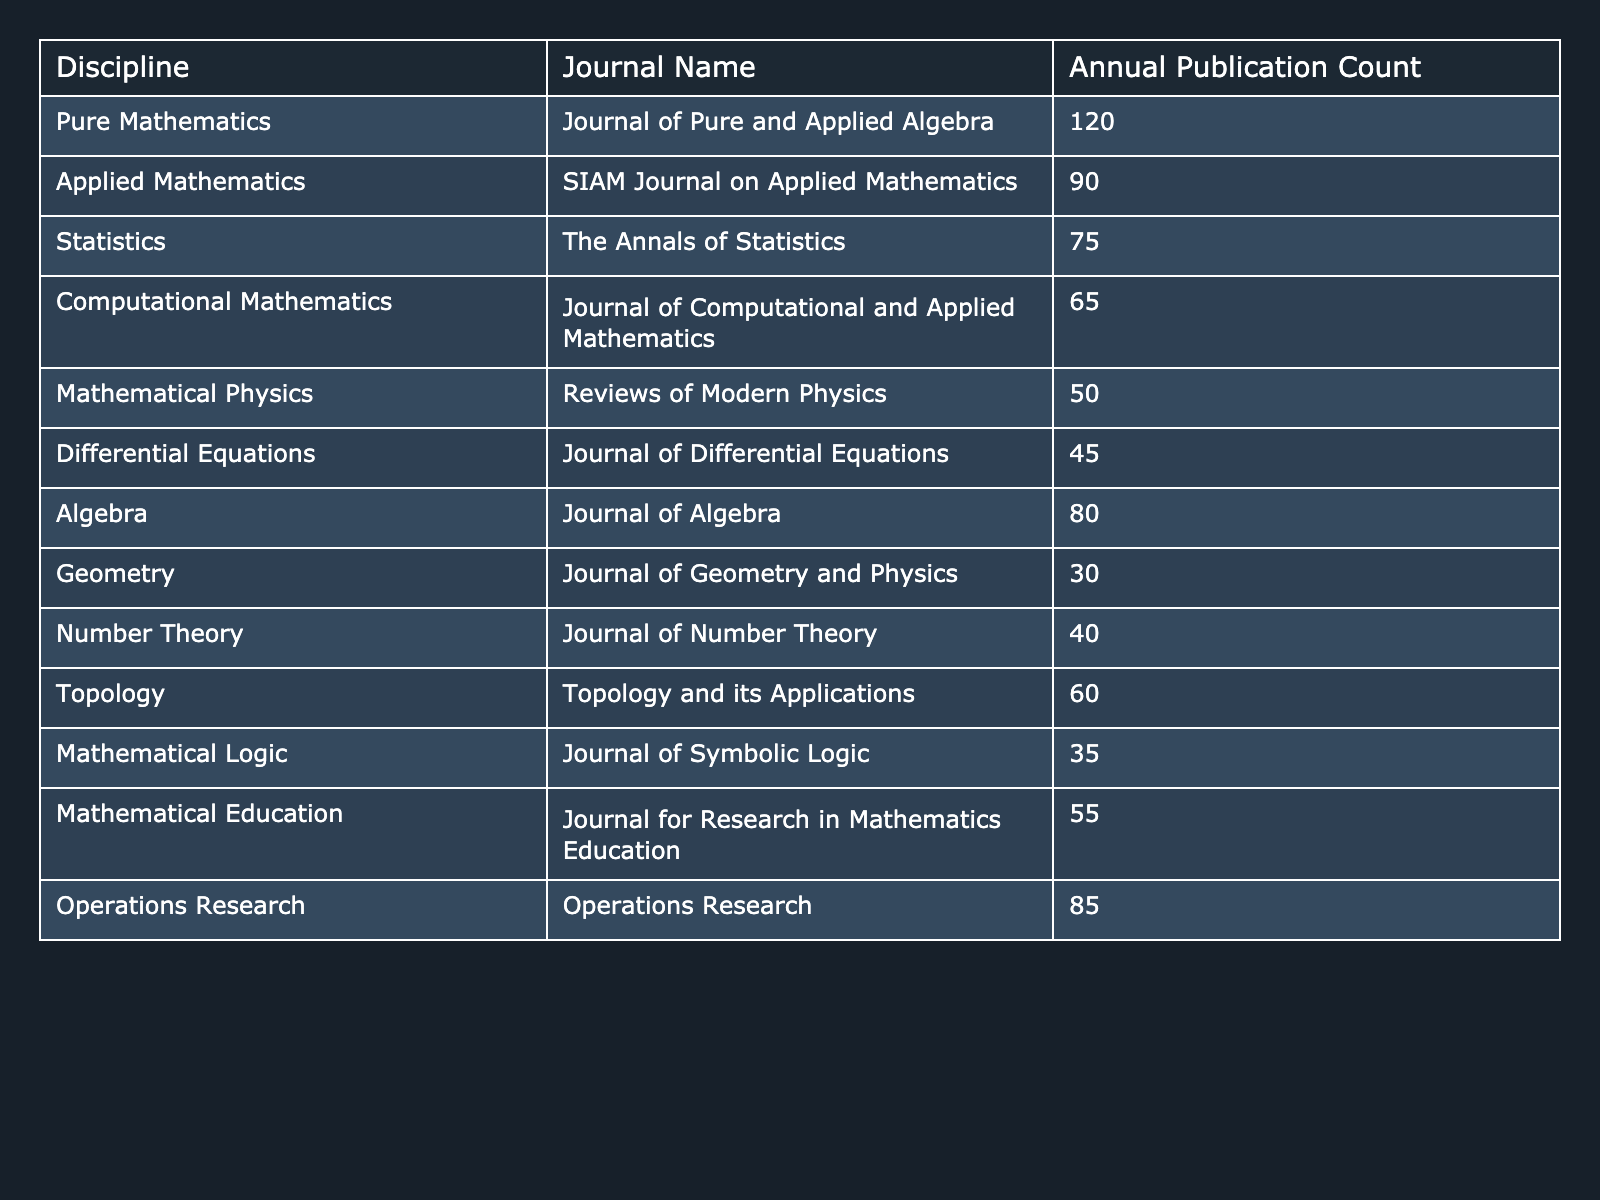What is the journal with the highest annual publication count? The maximum value in the "Annual Publication Count" column is 120, which corresponds to the "Journal of Pure and Applied Algebra" in the "Discipline" column.
Answer: Journal of Pure and Applied Algebra What is the annual publication count of the "SIAM Journal on Applied Mathematics"? The table lists "SIAM Journal on Applied Mathematics" under the "Applied Mathematics" discipline with an annual publication count of 90.
Answer: 90 Which discipline has the lowest annual publication count? Looking through the table, the lowest annual publication count is 30, associated with the "Journal of Geometry and Physics" under the "Geometry" discipline.
Answer: Geometry What is the combined annual publication count of journals in the "Statistics" and "Mathematical Logic" disciplines? The annual publication count for "The Annals of Statistics" is 75, and for "Journal of Symbolic Logic" it is 35. Adding these gives 75 + 35 = 110.
Answer: 110 Is there any journal in "Applied Mathematics" that has a higher publication count than "Journal for Research in Mathematics Education"? The "Journal for Research in Mathematics Education" has an annual publication count of 55. In "Applied Mathematics," the count is 90 for "SIAM Journal on Applied Mathematics," which is indeed higher.
Answer: Yes What is the average annual publication count across all disciplines listed? To find the average, sum all the counts: 120 + 90 + 75 + 65 + 50 + 45 + 80 + 30 + 40 + 60 + 35 + 55 + 85 =  835. There are 13 disciplines, so the average is 835 / 13 = 64.230769, rounding gives approximately 64.23.
Answer: 64.23 How many journals have an annual publication count greater than 60? By checking each annual publication count, we see "Journal of Pure and Applied Algebra," "SIAM Journal on Applied Mathematics," "Operations Research," "Algebra," and "Topology" have counts greater than 60, totaling 5 journals.
Answer: 5 What is the difference between the publication counts of "Journal of Algebra" and "Journal of Differential Equations"? "Journal of Algebra" has an annual publication count of 80, and "Journal of Differential Equations" has 45. The difference is calculated as 80 - 45 = 35.
Answer: 35 